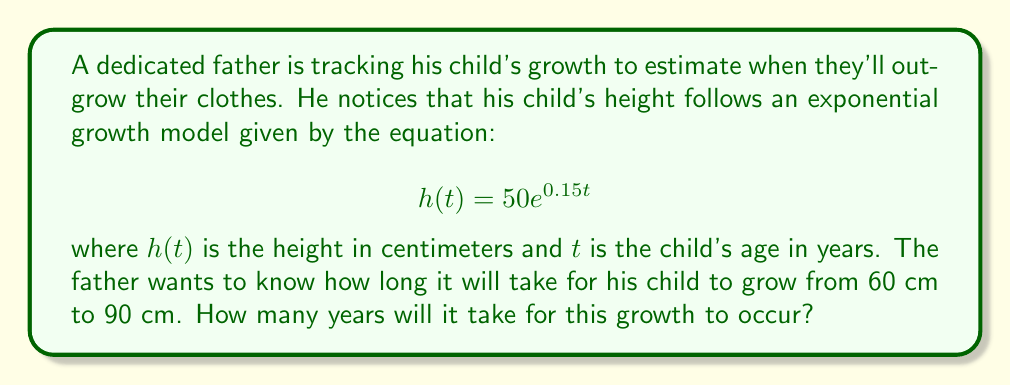Can you solve this math problem? To solve this problem, we need to use the given exponential growth model and determine the time it takes for the child to grow from 60 cm to 90 cm. Let's approach this step-by-step:

1. We start with the exponential growth model:
   $$h(t) = 50e^{0.15t}$$

2. We need to find the times $t_1$ and $t_2$ when the height is 60 cm and 90 cm respectively:

   For 60 cm: $60 = 50e^{0.15t_1}$
   For 90 cm: $90 = 50e^{0.15t_2}$

3. Let's solve for $t_1$:
   $$60 = 50e^{0.15t_1}$$
   $$\frac{60}{50} = e^{0.15t_1}$$
   $$1.2 = e^{0.15t_1}$$
   $$\ln(1.2) = 0.15t_1$$
   $$t_1 = \frac{\ln(1.2)}{0.15} \approx 1.22 \text{ years}$$

4. Now, let's solve for $t_2$:
   $$90 = 50e^{0.15t_2}$$
   $$\frac{90}{50} = e^{0.15t_2}$$
   $$1.8 = e^{0.15t_2}$$
   $$\ln(1.8) = 0.15t_2$$
   $$t_2 = \frac{\ln(1.8)}{0.15} \approx 3.92 \text{ years}$$

5. The time it takes to grow from 60 cm to 90 cm is the difference between $t_2$ and $t_1$:
   $$\text{Time} = t_2 - t_1 = 3.92 - 1.22 = 2.70 \text{ years}$$

Therefore, it will take approximately 2.70 years for the child to grow from 60 cm to 90 cm.
Answer: 2.70 years 